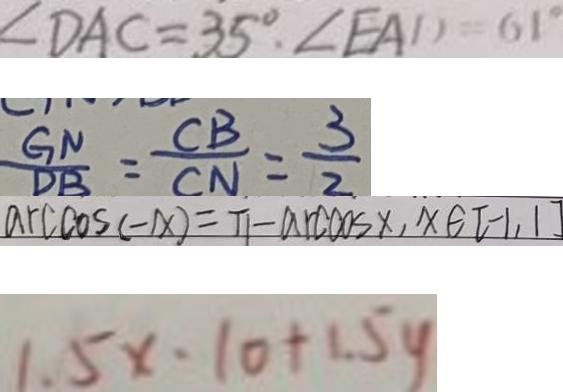Convert formula to latex. <formula><loc_0><loc_0><loc_500><loc_500>\angle D A C = 3 5 ^ { \circ } , \angle E A D = 6 1 ^ { \circ } 
 \frac { G N } { D B } = \frac { C B } { C N } = \frac { 3 } { 2 } 
 \arccos ( - x ) = \pi - \arccos ( x ) , x \in [ - 1 , 1 ] 
 1 . 5 x \cdot 1 0 + 1 . 5 y</formula> 